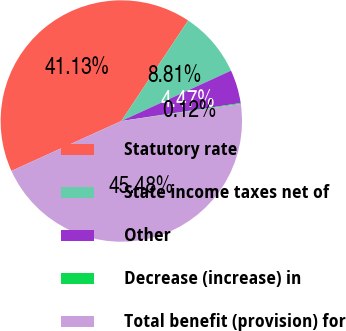<chart> <loc_0><loc_0><loc_500><loc_500><pie_chart><fcel>Statutory rate<fcel>State income taxes net of<fcel>Other<fcel>Decrease (increase) in<fcel>Total benefit (provision) for<nl><fcel>41.13%<fcel>8.81%<fcel>4.47%<fcel>0.12%<fcel>45.48%<nl></chart> 